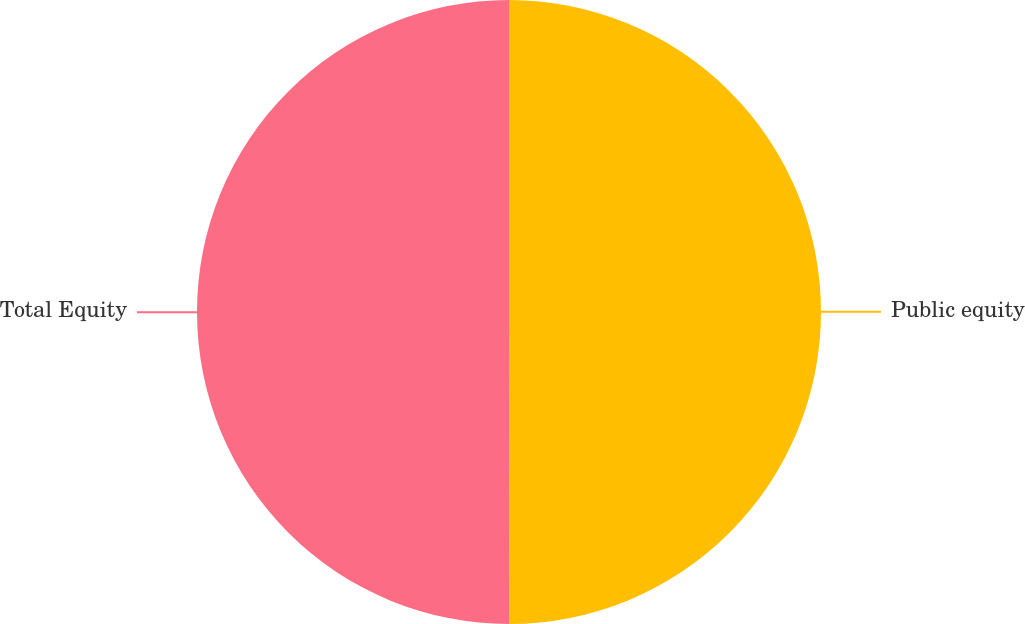Convert chart. <chart><loc_0><loc_0><loc_500><loc_500><pie_chart><fcel>Public equity<fcel>Total Equity<nl><fcel>49.98%<fcel>50.02%<nl></chart> 